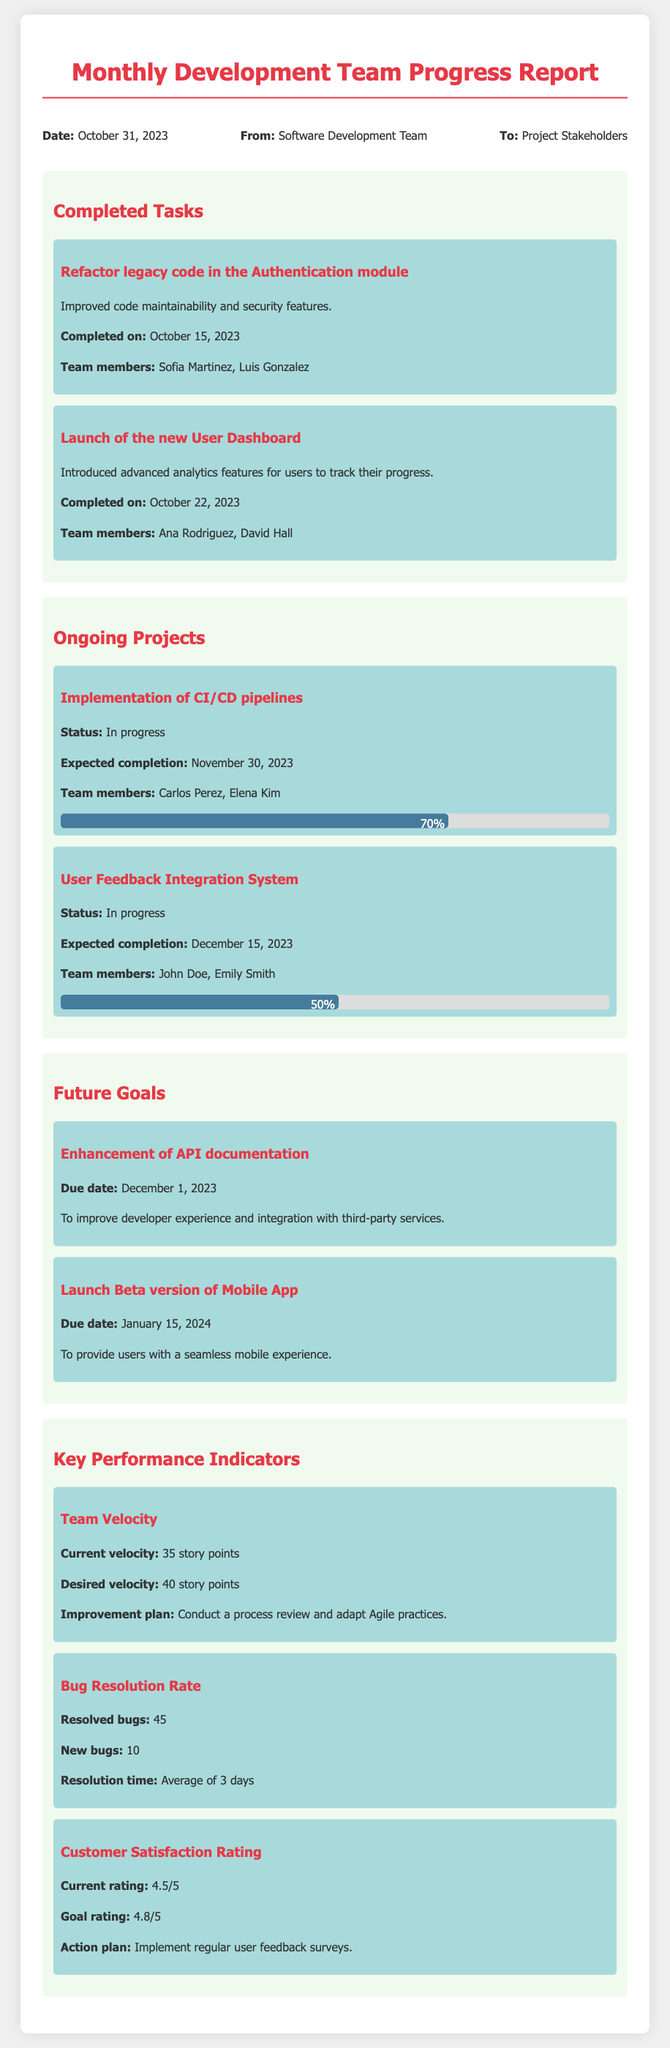What is the date of the report? The date of the report is explicitly mentioned in the header of the document.
Answer: October 31, 2023 Who completed the refactor of the Authentication module? The team members who worked on the refactor are listed in the completed tasks section.
Answer: Sofia Martinez, Luis Gonzalez What is the expected completion date for the User Feedback Integration System? The expected completion date is mentioned under the ongoing projects section.
Answer: December 15, 2023 What is the current team velocity? The current velocity is provided in the key performance indicators section.
Answer: 35 story points What is the goal rating for Customer Satisfaction? The goal rating is specified as part of the customer satisfaction details in the KPIs section.
Answer: 4.8/5 Which task was completed on October 22, 2023? The completed tasks section lists all completed tasks along with their completion dates.
Answer: Launch of the new User Dashboard What is the due date for enhancing API documentation? The due date is stated in the future goals section of the document.
Answer: December 1, 2023 What percentage of the CI/CD pipelines project is completed? The percentage of completion is noted within the progress bar under ongoing projects.
Answer: 70% 